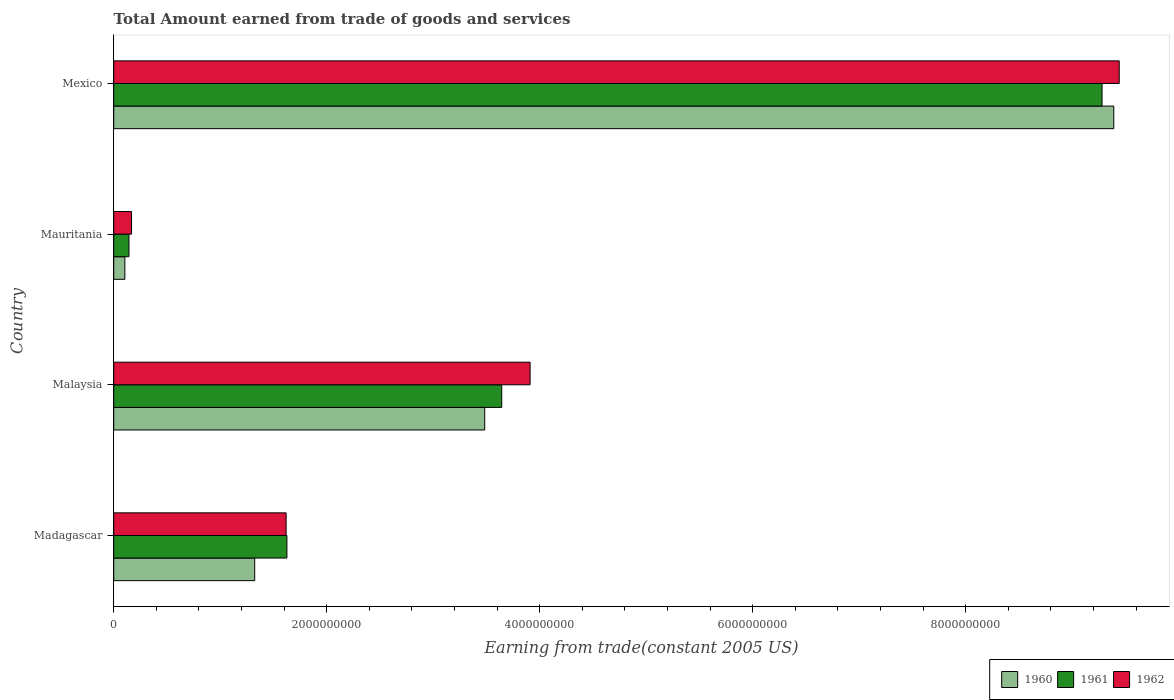What is the total amount earned by trading goods and services in 1962 in Mauritania?
Your answer should be very brief. 1.67e+08. Across all countries, what is the maximum total amount earned by trading goods and services in 1961?
Make the answer very short. 9.28e+09. Across all countries, what is the minimum total amount earned by trading goods and services in 1962?
Make the answer very short. 1.67e+08. In which country was the total amount earned by trading goods and services in 1960 minimum?
Provide a succinct answer. Mauritania. What is the total total amount earned by trading goods and services in 1960 in the graph?
Offer a very short reply. 1.43e+1. What is the difference between the total amount earned by trading goods and services in 1961 in Madagascar and that in Mexico?
Your answer should be compact. -7.65e+09. What is the difference between the total amount earned by trading goods and services in 1960 in Mauritania and the total amount earned by trading goods and services in 1961 in Madagascar?
Provide a short and direct response. -1.52e+09. What is the average total amount earned by trading goods and services in 1962 per country?
Your answer should be compact. 3.78e+09. What is the difference between the total amount earned by trading goods and services in 1960 and total amount earned by trading goods and services in 1962 in Mexico?
Provide a succinct answer. -5.10e+07. What is the ratio of the total amount earned by trading goods and services in 1962 in Madagascar to that in Mexico?
Keep it short and to the point. 0.17. Is the total amount earned by trading goods and services in 1962 in Madagascar less than that in Malaysia?
Offer a terse response. Yes. What is the difference between the highest and the second highest total amount earned by trading goods and services in 1960?
Your answer should be very brief. 5.91e+09. What is the difference between the highest and the lowest total amount earned by trading goods and services in 1961?
Your response must be concise. 9.14e+09. What does the 1st bar from the top in Mexico represents?
Your answer should be very brief. 1962. Is it the case that in every country, the sum of the total amount earned by trading goods and services in 1960 and total amount earned by trading goods and services in 1962 is greater than the total amount earned by trading goods and services in 1961?
Keep it short and to the point. Yes. How many bars are there?
Ensure brevity in your answer.  12. Are all the bars in the graph horizontal?
Offer a terse response. Yes. What is the difference between two consecutive major ticks on the X-axis?
Provide a succinct answer. 2.00e+09. Does the graph contain any zero values?
Provide a short and direct response. No. Where does the legend appear in the graph?
Offer a terse response. Bottom right. How are the legend labels stacked?
Provide a short and direct response. Horizontal. What is the title of the graph?
Provide a short and direct response. Total Amount earned from trade of goods and services. Does "1993" appear as one of the legend labels in the graph?
Your response must be concise. No. What is the label or title of the X-axis?
Make the answer very short. Earning from trade(constant 2005 US). What is the Earning from trade(constant 2005 US) in 1960 in Madagascar?
Your response must be concise. 1.32e+09. What is the Earning from trade(constant 2005 US) of 1961 in Madagascar?
Your answer should be compact. 1.63e+09. What is the Earning from trade(constant 2005 US) in 1962 in Madagascar?
Keep it short and to the point. 1.62e+09. What is the Earning from trade(constant 2005 US) of 1960 in Malaysia?
Provide a short and direct response. 3.48e+09. What is the Earning from trade(constant 2005 US) of 1961 in Malaysia?
Your response must be concise. 3.64e+09. What is the Earning from trade(constant 2005 US) in 1962 in Malaysia?
Offer a terse response. 3.91e+09. What is the Earning from trade(constant 2005 US) of 1960 in Mauritania?
Keep it short and to the point. 1.04e+08. What is the Earning from trade(constant 2005 US) of 1961 in Mauritania?
Make the answer very short. 1.43e+08. What is the Earning from trade(constant 2005 US) of 1962 in Mauritania?
Provide a short and direct response. 1.67e+08. What is the Earning from trade(constant 2005 US) in 1960 in Mexico?
Give a very brief answer. 9.39e+09. What is the Earning from trade(constant 2005 US) of 1961 in Mexico?
Give a very brief answer. 9.28e+09. What is the Earning from trade(constant 2005 US) of 1962 in Mexico?
Make the answer very short. 9.44e+09. Across all countries, what is the maximum Earning from trade(constant 2005 US) in 1960?
Offer a terse response. 9.39e+09. Across all countries, what is the maximum Earning from trade(constant 2005 US) in 1961?
Ensure brevity in your answer.  9.28e+09. Across all countries, what is the maximum Earning from trade(constant 2005 US) in 1962?
Your response must be concise. 9.44e+09. Across all countries, what is the minimum Earning from trade(constant 2005 US) of 1960?
Ensure brevity in your answer.  1.04e+08. Across all countries, what is the minimum Earning from trade(constant 2005 US) in 1961?
Give a very brief answer. 1.43e+08. Across all countries, what is the minimum Earning from trade(constant 2005 US) of 1962?
Your response must be concise. 1.67e+08. What is the total Earning from trade(constant 2005 US) in 1960 in the graph?
Your response must be concise. 1.43e+1. What is the total Earning from trade(constant 2005 US) of 1961 in the graph?
Offer a very short reply. 1.47e+1. What is the total Earning from trade(constant 2005 US) in 1962 in the graph?
Offer a very short reply. 1.51e+1. What is the difference between the Earning from trade(constant 2005 US) of 1960 in Madagascar and that in Malaysia?
Your answer should be very brief. -2.16e+09. What is the difference between the Earning from trade(constant 2005 US) in 1961 in Madagascar and that in Malaysia?
Offer a very short reply. -2.02e+09. What is the difference between the Earning from trade(constant 2005 US) of 1962 in Madagascar and that in Malaysia?
Your answer should be compact. -2.29e+09. What is the difference between the Earning from trade(constant 2005 US) of 1960 in Madagascar and that in Mauritania?
Your answer should be very brief. 1.22e+09. What is the difference between the Earning from trade(constant 2005 US) in 1961 in Madagascar and that in Mauritania?
Offer a terse response. 1.48e+09. What is the difference between the Earning from trade(constant 2005 US) in 1962 in Madagascar and that in Mauritania?
Your response must be concise. 1.45e+09. What is the difference between the Earning from trade(constant 2005 US) of 1960 in Madagascar and that in Mexico?
Your answer should be compact. -8.07e+09. What is the difference between the Earning from trade(constant 2005 US) in 1961 in Madagascar and that in Mexico?
Give a very brief answer. -7.65e+09. What is the difference between the Earning from trade(constant 2005 US) in 1962 in Madagascar and that in Mexico?
Keep it short and to the point. -7.82e+09. What is the difference between the Earning from trade(constant 2005 US) in 1960 in Malaysia and that in Mauritania?
Your answer should be very brief. 3.38e+09. What is the difference between the Earning from trade(constant 2005 US) of 1961 in Malaysia and that in Mauritania?
Provide a short and direct response. 3.50e+09. What is the difference between the Earning from trade(constant 2005 US) in 1962 in Malaysia and that in Mauritania?
Offer a very short reply. 3.74e+09. What is the difference between the Earning from trade(constant 2005 US) of 1960 in Malaysia and that in Mexico?
Make the answer very short. -5.91e+09. What is the difference between the Earning from trade(constant 2005 US) in 1961 in Malaysia and that in Mexico?
Your response must be concise. -5.64e+09. What is the difference between the Earning from trade(constant 2005 US) in 1962 in Malaysia and that in Mexico?
Your answer should be very brief. -5.53e+09. What is the difference between the Earning from trade(constant 2005 US) in 1960 in Mauritania and that in Mexico?
Your response must be concise. -9.29e+09. What is the difference between the Earning from trade(constant 2005 US) of 1961 in Mauritania and that in Mexico?
Provide a succinct answer. -9.14e+09. What is the difference between the Earning from trade(constant 2005 US) in 1962 in Mauritania and that in Mexico?
Provide a short and direct response. -9.28e+09. What is the difference between the Earning from trade(constant 2005 US) of 1960 in Madagascar and the Earning from trade(constant 2005 US) of 1961 in Malaysia?
Ensure brevity in your answer.  -2.32e+09. What is the difference between the Earning from trade(constant 2005 US) of 1960 in Madagascar and the Earning from trade(constant 2005 US) of 1962 in Malaysia?
Your answer should be compact. -2.59e+09. What is the difference between the Earning from trade(constant 2005 US) in 1961 in Madagascar and the Earning from trade(constant 2005 US) in 1962 in Malaysia?
Your answer should be compact. -2.28e+09. What is the difference between the Earning from trade(constant 2005 US) in 1960 in Madagascar and the Earning from trade(constant 2005 US) in 1961 in Mauritania?
Offer a terse response. 1.18e+09. What is the difference between the Earning from trade(constant 2005 US) of 1960 in Madagascar and the Earning from trade(constant 2005 US) of 1962 in Mauritania?
Offer a very short reply. 1.16e+09. What is the difference between the Earning from trade(constant 2005 US) in 1961 in Madagascar and the Earning from trade(constant 2005 US) in 1962 in Mauritania?
Provide a succinct answer. 1.46e+09. What is the difference between the Earning from trade(constant 2005 US) in 1960 in Madagascar and the Earning from trade(constant 2005 US) in 1961 in Mexico?
Offer a terse response. -7.96e+09. What is the difference between the Earning from trade(constant 2005 US) in 1960 in Madagascar and the Earning from trade(constant 2005 US) in 1962 in Mexico?
Keep it short and to the point. -8.12e+09. What is the difference between the Earning from trade(constant 2005 US) of 1961 in Madagascar and the Earning from trade(constant 2005 US) of 1962 in Mexico?
Provide a succinct answer. -7.82e+09. What is the difference between the Earning from trade(constant 2005 US) of 1960 in Malaysia and the Earning from trade(constant 2005 US) of 1961 in Mauritania?
Your answer should be very brief. 3.34e+09. What is the difference between the Earning from trade(constant 2005 US) in 1960 in Malaysia and the Earning from trade(constant 2005 US) in 1962 in Mauritania?
Your answer should be compact. 3.32e+09. What is the difference between the Earning from trade(constant 2005 US) in 1961 in Malaysia and the Earning from trade(constant 2005 US) in 1962 in Mauritania?
Make the answer very short. 3.48e+09. What is the difference between the Earning from trade(constant 2005 US) in 1960 in Malaysia and the Earning from trade(constant 2005 US) in 1961 in Mexico?
Ensure brevity in your answer.  -5.80e+09. What is the difference between the Earning from trade(constant 2005 US) of 1960 in Malaysia and the Earning from trade(constant 2005 US) of 1962 in Mexico?
Keep it short and to the point. -5.96e+09. What is the difference between the Earning from trade(constant 2005 US) of 1961 in Malaysia and the Earning from trade(constant 2005 US) of 1962 in Mexico?
Make the answer very short. -5.80e+09. What is the difference between the Earning from trade(constant 2005 US) of 1960 in Mauritania and the Earning from trade(constant 2005 US) of 1961 in Mexico?
Keep it short and to the point. -9.18e+09. What is the difference between the Earning from trade(constant 2005 US) of 1960 in Mauritania and the Earning from trade(constant 2005 US) of 1962 in Mexico?
Provide a succinct answer. -9.34e+09. What is the difference between the Earning from trade(constant 2005 US) in 1961 in Mauritania and the Earning from trade(constant 2005 US) in 1962 in Mexico?
Provide a short and direct response. -9.30e+09. What is the average Earning from trade(constant 2005 US) in 1960 per country?
Keep it short and to the point. 3.58e+09. What is the average Earning from trade(constant 2005 US) of 1961 per country?
Provide a short and direct response. 3.67e+09. What is the average Earning from trade(constant 2005 US) of 1962 per country?
Keep it short and to the point. 3.78e+09. What is the difference between the Earning from trade(constant 2005 US) in 1960 and Earning from trade(constant 2005 US) in 1961 in Madagascar?
Your answer should be very brief. -3.02e+08. What is the difference between the Earning from trade(constant 2005 US) in 1960 and Earning from trade(constant 2005 US) in 1962 in Madagascar?
Your answer should be very brief. -2.95e+08. What is the difference between the Earning from trade(constant 2005 US) in 1961 and Earning from trade(constant 2005 US) in 1962 in Madagascar?
Offer a terse response. 7.38e+06. What is the difference between the Earning from trade(constant 2005 US) of 1960 and Earning from trade(constant 2005 US) of 1961 in Malaysia?
Offer a terse response. -1.60e+08. What is the difference between the Earning from trade(constant 2005 US) in 1960 and Earning from trade(constant 2005 US) in 1962 in Malaysia?
Your response must be concise. -4.26e+08. What is the difference between the Earning from trade(constant 2005 US) of 1961 and Earning from trade(constant 2005 US) of 1962 in Malaysia?
Give a very brief answer. -2.67e+08. What is the difference between the Earning from trade(constant 2005 US) in 1960 and Earning from trade(constant 2005 US) in 1961 in Mauritania?
Make the answer very short. -3.85e+07. What is the difference between the Earning from trade(constant 2005 US) in 1960 and Earning from trade(constant 2005 US) in 1962 in Mauritania?
Ensure brevity in your answer.  -6.27e+07. What is the difference between the Earning from trade(constant 2005 US) of 1961 and Earning from trade(constant 2005 US) of 1962 in Mauritania?
Offer a very short reply. -2.42e+07. What is the difference between the Earning from trade(constant 2005 US) of 1960 and Earning from trade(constant 2005 US) of 1961 in Mexico?
Provide a succinct answer. 1.10e+08. What is the difference between the Earning from trade(constant 2005 US) of 1960 and Earning from trade(constant 2005 US) of 1962 in Mexico?
Your response must be concise. -5.10e+07. What is the difference between the Earning from trade(constant 2005 US) of 1961 and Earning from trade(constant 2005 US) of 1962 in Mexico?
Provide a short and direct response. -1.61e+08. What is the ratio of the Earning from trade(constant 2005 US) of 1960 in Madagascar to that in Malaysia?
Offer a very short reply. 0.38. What is the ratio of the Earning from trade(constant 2005 US) of 1961 in Madagascar to that in Malaysia?
Keep it short and to the point. 0.45. What is the ratio of the Earning from trade(constant 2005 US) in 1962 in Madagascar to that in Malaysia?
Offer a very short reply. 0.41. What is the ratio of the Earning from trade(constant 2005 US) of 1960 in Madagascar to that in Mauritania?
Ensure brevity in your answer.  12.69. What is the ratio of the Earning from trade(constant 2005 US) of 1961 in Madagascar to that in Mauritania?
Your answer should be compact. 11.38. What is the ratio of the Earning from trade(constant 2005 US) in 1962 in Madagascar to that in Mauritania?
Keep it short and to the point. 9.69. What is the ratio of the Earning from trade(constant 2005 US) of 1960 in Madagascar to that in Mexico?
Provide a short and direct response. 0.14. What is the ratio of the Earning from trade(constant 2005 US) in 1961 in Madagascar to that in Mexico?
Make the answer very short. 0.18. What is the ratio of the Earning from trade(constant 2005 US) in 1962 in Madagascar to that in Mexico?
Provide a short and direct response. 0.17. What is the ratio of the Earning from trade(constant 2005 US) in 1960 in Malaysia to that in Mauritania?
Offer a very short reply. 33.39. What is the ratio of the Earning from trade(constant 2005 US) of 1961 in Malaysia to that in Mauritania?
Provide a succinct answer. 25.51. What is the ratio of the Earning from trade(constant 2005 US) of 1962 in Malaysia to that in Mauritania?
Provide a short and direct response. 23.41. What is the ratio of the Earning from trade(constant 2005 US) in 1960 in Malaysia to that in Mexico?
Give a very brief answer. 0.37. What is the ratio of the Earning from trade(constant 2005 US) of 1961 in Malaysia to that in Mexico?
Offer a terse response. 0.39. What is the ratio of the Earning from trade(constant 2005 US) of 1962 in Malaysia to that in Mexico?
Make the answer very short. 0.41. What is the ratio of the Earning from trade(constant 2005 US) in 1960 in Mauritania to that in Mexico?
Offer a very short reply. 0.01. What is the ratio of the Earning from trade(constant 2005 US) in 1961 in Mauritania to that in Mexico?
Keep it short and to the point. 0.02. What is the ratio of the Earning from trade(constant 2005 US) in 1962 in Mauritania to that in Mexico?
Give a very brief answer. 0.02. What is the difference between the highest and the second highest Earning from trade(constant 2005 US) in 1960?
Give a very brief answer. 5.91e+09. What is the difference between the highest and the second highest Earning from trade(constant 2005 US) in 1961?
Offer a terse response. 5.64e+09. What is the difference between the highest and the second highest Earning from trade(constant 2005 US) of 1962?
Offer a terse response. 5.53e+09. What is the difference between the highest and the lowest Earning from trade(constant 2005 US) in 1960?
Provide a short and direct response. 9.29e+09. What is the difference between the highest and the lowest Earning from trade(constant 2005 US) in 1961?
Make the answer very short. 9.14e+09. What is the difference between the highest and the lowest Earning from trade(constant 2005 US) in 1962?
Ensure brevity in your answer.  9.28e+09. 